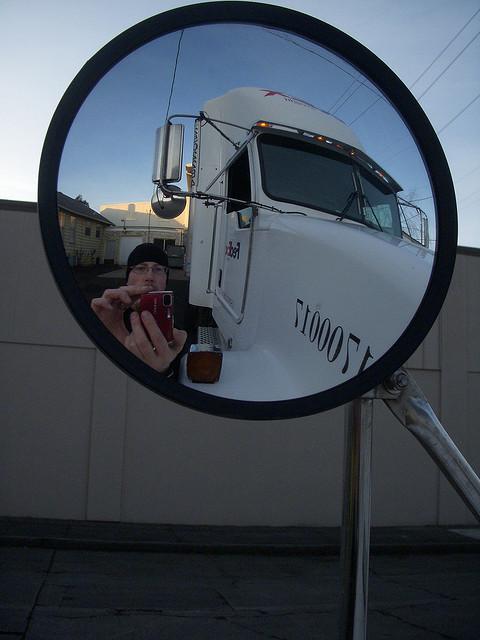What is the vehicle in the mirror?
Concise answer only. Truck. What color is the bus in the mirror?
Be succinct. White. What color is the object?
Be succinct. White. Is the mirror cracked?
Quick response, please. No. Is he taking this pic with a phone or a camera?
Be succinct. Phone. What is the man wearing on his head?
Give a very brief answer. Hat. What is in the cup next to the driver?
Be succinct. Coffee. What does the writing on the right say?
Answer briefly. 1700017. What device does the man use to take the photo?
Concise answer only. Cell phone. Is there a reflection on the mirror?
Be succinct. Yes. What type of vehicle is the mirror attached to?
Quick response, please. Truck. Is he having fun?
Keep it brief. Yes. What color is the truck cab?
Write a very short answer. White. What is the green thing being reflected on the mirror?
Be succinct. Truck. 